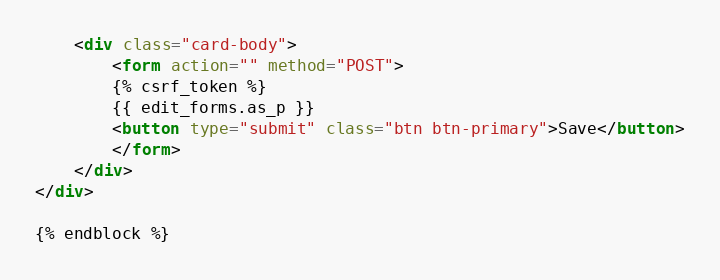<code> <loc_0><loc_0><loc_500><loc_500><_HTML_>    <div class="card-body">
        <form action="" method="POST">
        {% csrf_token %}
        {{ edit_forms.as_p }}
        <button type="submit" class="btn btn-primary">Save</button>
        </form>
    </div>
</div>

{% endblock %}

</code> 